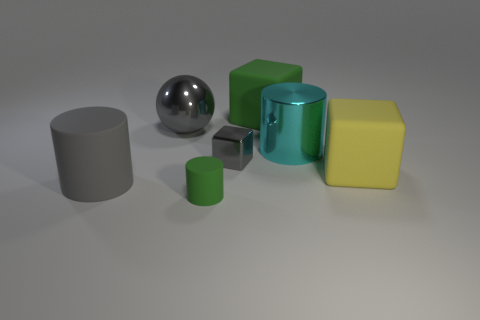Can you describe the lighting and shadows present in the scene? Certainly, the scene is softly illuminated from the top, creating gentle shadows that trail off to the right of the objects. This suggests a single diffuse light source, providing an evenly lit environment. The shadows contribute to the three-dimensional appearance of the objects, enhancing their forms and the spatial relationships between them. 